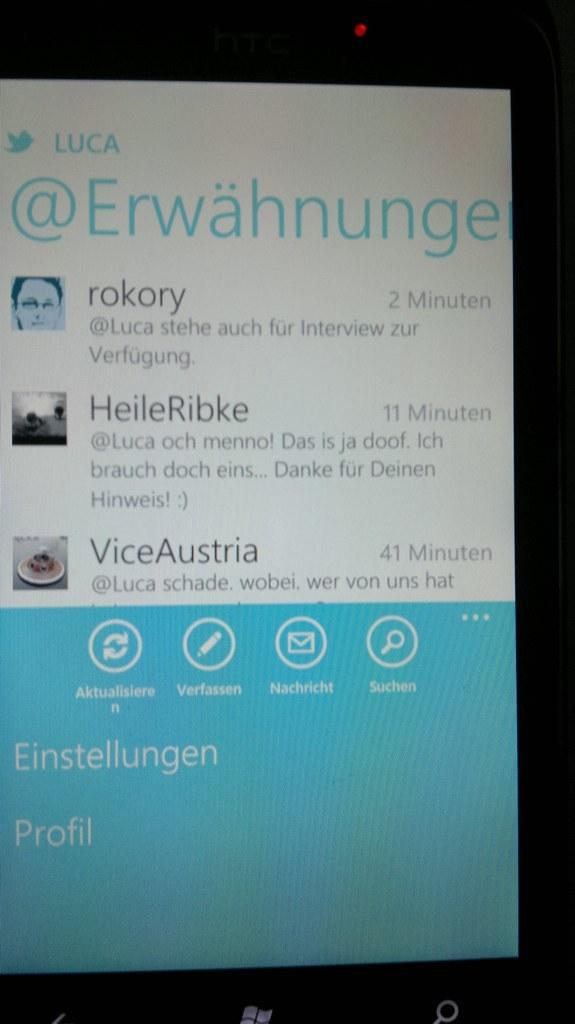<image>
Summarize the visual content of the image. Luca has received messages from Rokory, HeileRibke, and Vice Austria in the last hour. 